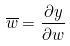<formula> <loc_0><loc_0><loc_500><loc_500>\overline { w } = \frac { \partial y } { \partial w }</formula> 